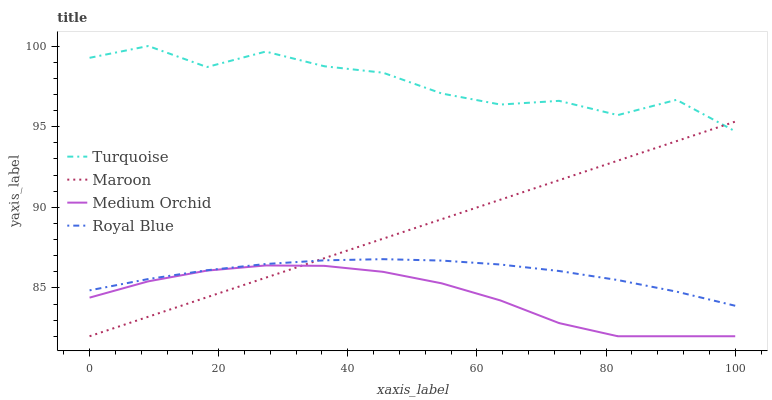Does Medium Orchid have the minimum area under the curve?
Answer yes or no. Yes. Does Turquoise have the minimum area under the curve?
Answer yes or no. No. Does Medium Orchid have the maximum area under the curve?
Answer yes or no. No. Is Medium Orchid the smoothest?
Answer yes or no. No. Is Medium Orchid the roughest?
Answer yes or no. No. Does Turquoise have the lowest value?
Answer yes or no. No. Does Medium Orchid have the highest value?
Answer yes or no. No. Is Medium Orchid less than Turquoise?
Answer yes or no. Yes. Is Turquoise greater than Royal Blue?
Answer yes or no. Yes. Does Medium Orchid intersect Turquoise?
Answer yes or no. No. 